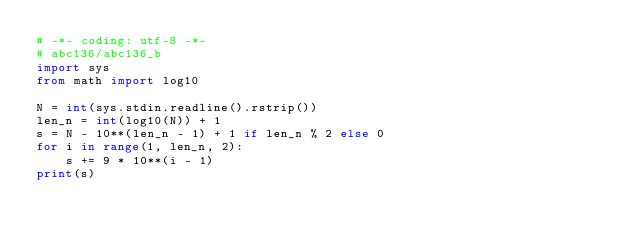Convert code to text. <code><loc_0><loc_0><loc_500><loc_500><_Python_># -*- coding: utf-8 -*-
# abc136/abc136_b
import sys
from math import log10

N = int(sys.stdin.readline().rstrip())
len_n = int(log10(N)) + 1
s = N - 10**(len_n - 1) + 1 if len_n % 2 else 0
for i in range(1, len_n, 2):
    s += 9 * 10**(i - 1)
print(s)
</code> 